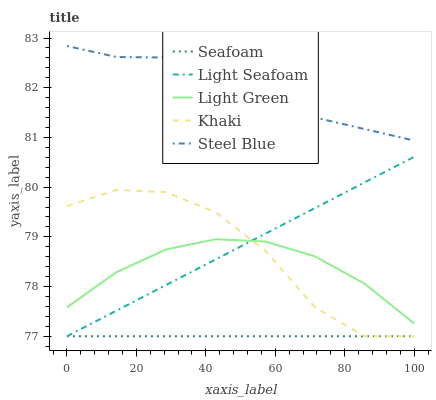Does Seafoam have the minimum area under the curve?
Answer yes or no. Yes. Does Steel Blue have the maximum area under the curve?
Answer yes or no. Yes. Does Khaki have the minimum area under the curve?
Answer yes or no. No. Does Khaki have the maximum area under the curve?
Answer yes or no. No. Is Seafoam the smoothest?
Answer yes or no. Yes. Is Khaki the roughest?
Answer yes or no. Yes. Is Khaki the smoothest?
Answer yes or no. No. Is Seafoam the roughest?
Answer yes or no. No. Does Light Seafoam have the lowest value?
Answer yes or no. Yes. Does Light Green have the lowest value?
Answer yes or no. No. Does Steel Blue have the highest value?
Answer yes or no. Yes. Does Khaki have the highest value?
Answer yes or no. No. Is Light Seafoam less than Steel Blue?
Answer yes or no. Yes. Is Steel Blue greater than Seafoam?
Answer yes or no. Yes. Does Seafoam intersect Light Seafoam?
Answer yes or no. Yes. Is Seafoam less than Light Seafoam?
Answer yes or no. No. Is Seafoam greater than Light Seafoam?
Answer yes or no. No. Does Light Seafoam intersect Steel Blue?
Answer yes or no. No. 